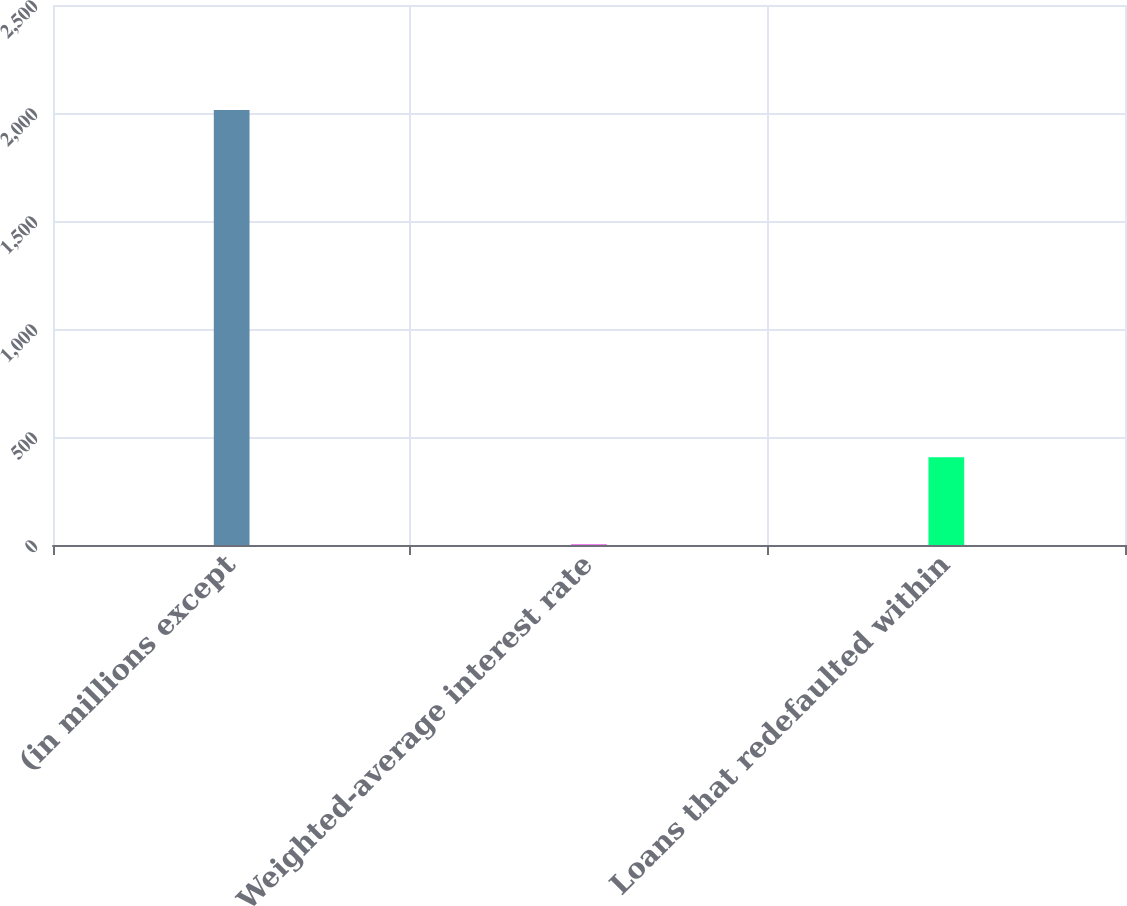<chart> <loc_0><loc_0><loc_500><loc_500><bar_chart><fcel>(in millions except<fcel>Weighted-average interest rate<fcel>Loans that redefaulted within<nl><fcel>2014<fcel>4.4<fcel>406.32<nl></chart> 